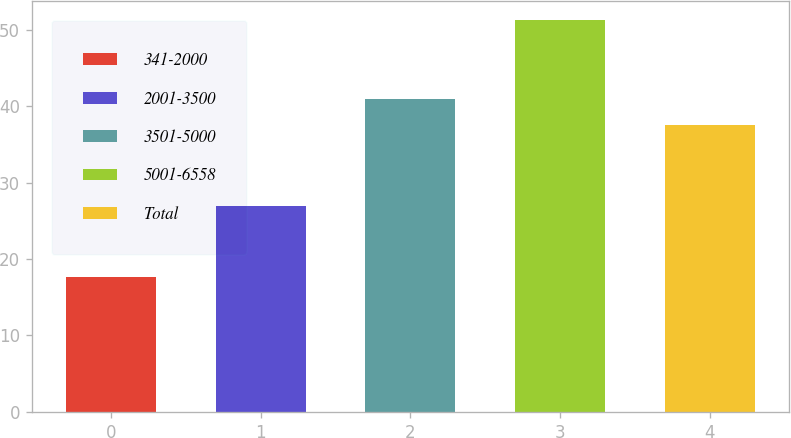Convert chart to OTSL. <chart><loc_0><loc_0><loc_500><loc_500><bar_chart><fcel>341-2000<fcel>2001-3500<fcel>3501-5000<fcel>5001-6558<fcel>Total<nl><fcel>17.67<fcel>26.99<fcel>40.95<fcel>51.27<fcel>37.59<nl></chart> 